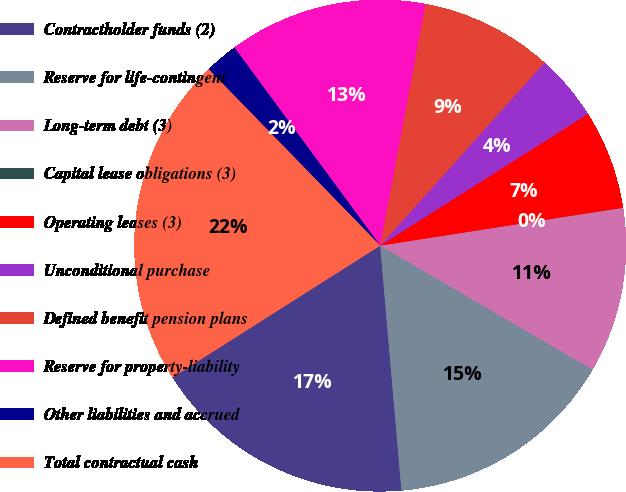<chart> <loc_0><loc_0><loc_500><loc_500><pie_chart><fcel>Contractholder funds (2)<fcel>Reserve for life-contingent<fcel>Long-term debt (3)<fcel>Capital lease obligations (3)<fcel>Operating leases (3)<fcel>Unconditional purchase<fcel>Defined benefit pension plans<fcel>Reserve for property-liability<fcel>Other liabilities and accrued<fcel>Total contractual cash<nl><fcel>17.38%<fcel>15.21%<fcel>10.87%<fcel>0.01%<fcel>6.53%<fcel>4.36%<fcel>8.7%<fcel>13.04%<fcel>2.18%<fcel>21.72%<nl></chart> 